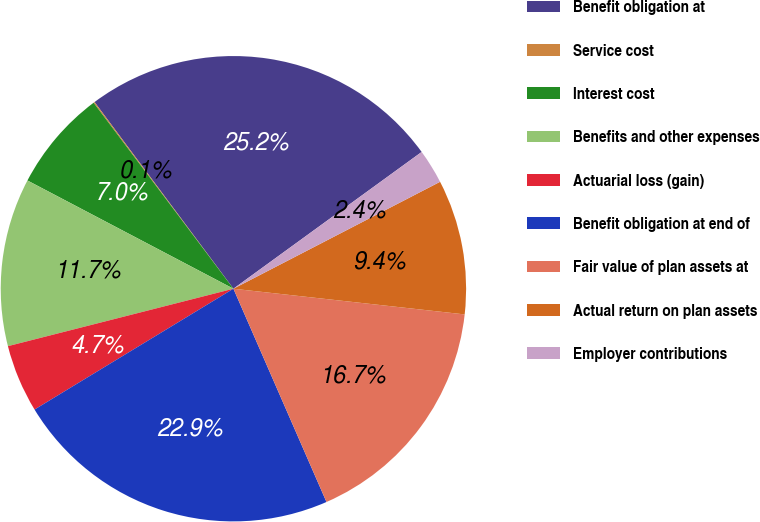Convert chart. <chart><loc_0><loc_0><loc_500><loc_500><pie_chart><fcel>Benefit obligation at<fcel>Service cost<fcel>Interest cost<fcel>Benefits and other expenses<fcel>Actuarial loss (gain)<fcel>Benefit obligation at end of<fcel>Fair value of plan assets at<fcel>Actual return on plan assets<fcel>Employer contributions<nl><fcel>25.18%<fcel>0.08%<fcel>7.04%<fcel>11.67%<fcel>4.72%<fcel>22.86%<fcel>16.69%<fcel>9.36%<fcel>2.4%<nl></chart> 